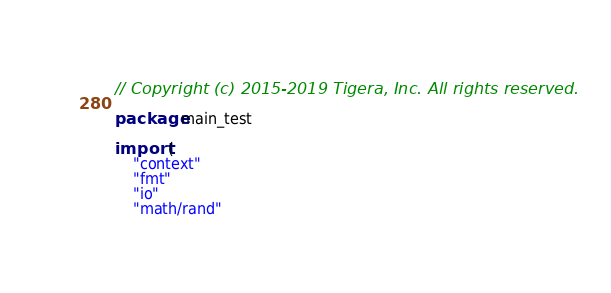<code> <loc_0><loc_0><loc_500><loc_500><_Go_>// Copyright (c) 2015-2019 Tigera, Inc. All rights reserved.

package main_test

import (
	"context"
	"fmt"
	"io"
	"math/rand"</code> 